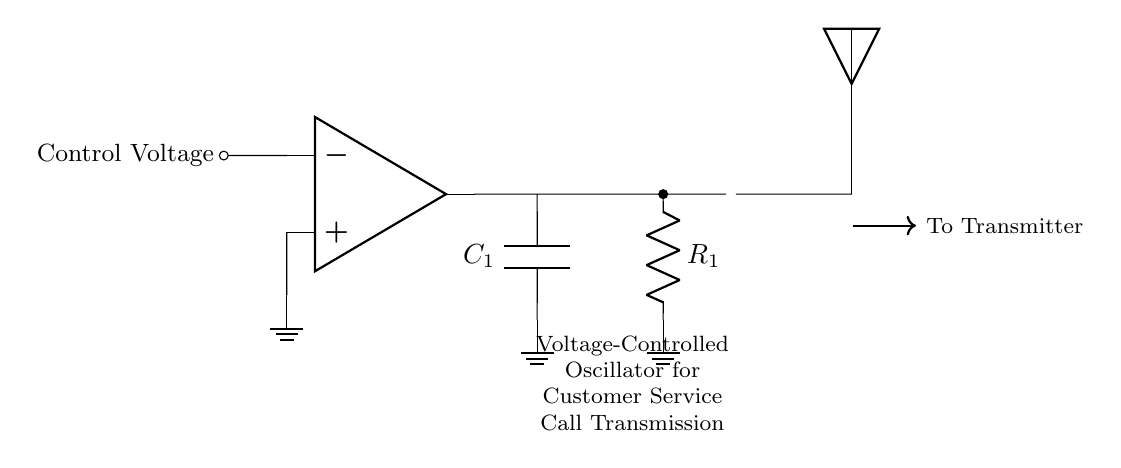What is the output component in this circuit? The output component is the voltage-controlled oscillator represented as VCO in the diagram. It is labeled clearly in the circuit output section.
Answer: VCO What does the capacitor in the circuit represent? The capacitor, labeled as C1, is a fundamental component that stores electrical energy temporarily. Its placement in the output suggests it plays a role in filtering or timing within the oscillator circuit.
Answer: C1 How many resistors are shown in the circuit? The circuit contains one resistor labeled R1. It is positioned between the output of the voltage-controlled oscillator and ground, serving to control the current in the circuit.
Answer: 1 What is the function of the control voltage? The control voltage is connected to the inverting input of the op-amp, influencing the frequency or output voltage of the oscillator based on variations in this voltage.
Answer: Frequency control How does this oscillator connect to the transmitter? There is a direct connection indicated by a thick arrow leading from the output of the VCO to the transmitter. It shows that the oscillator output feeds into the transmitting component of the telecom equipment.
Answer: To Transmitter What role does the resistor play in this oscillator circuit? Resistor R1 is critical in determining the time constant of the circuit, affecting how the voltage across the capacitor changes over time, which in turn influences the oscillation frequency.
Answer: Time constant 